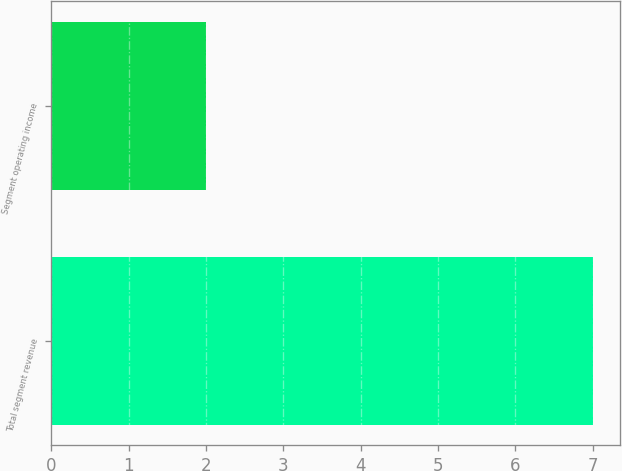<chart> <loc_0><loc_0><loc_500><loc_500><bar_chart><fcel>Total segment revenue<fcel>Segment operating income<nl><fcel>7<fcel>2<nl></chart> 